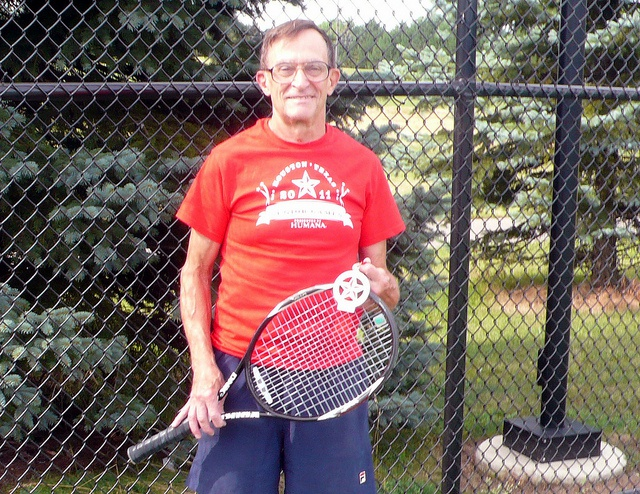Describe the objects in this image and their specific colors. I can see people in gray, salmon, white, navy, and lightpink tones and tennis racket in gray, lavender, darkgray, and brown tones in this image. 